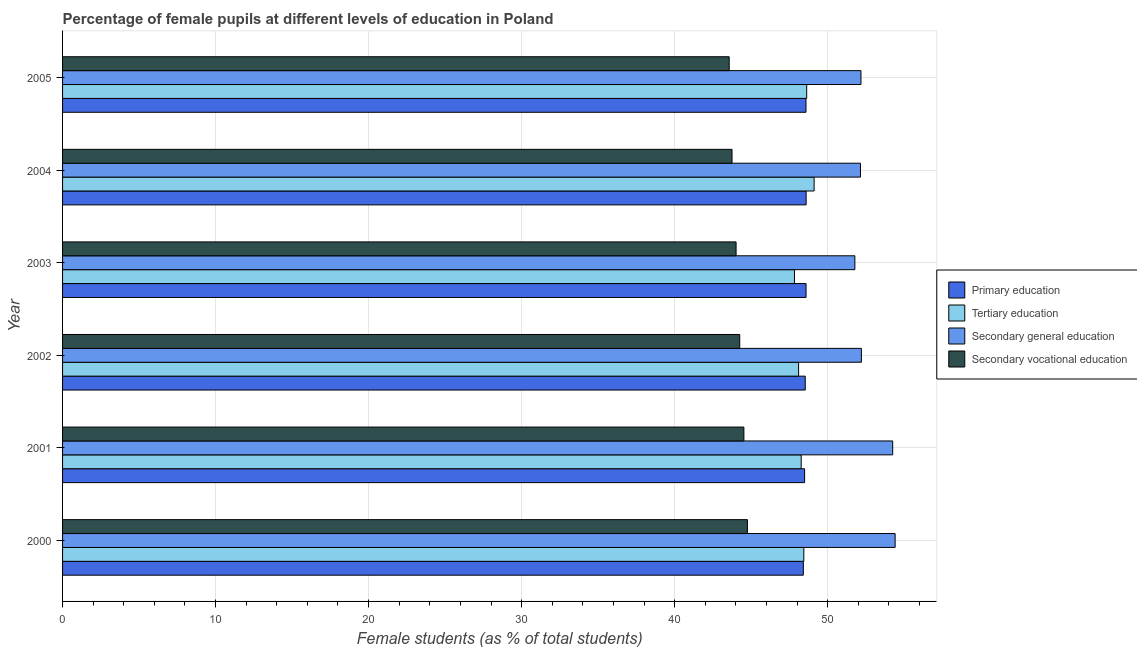How many different coloured bars are there?
Your response must be concise. 4. How many groups of bars are there?
Your answer should be very brief. 6. In how many cases, is the number of bars for a given year not equal to the number of legend labels?
Offer a very short reply. 0. What is the percentage of female students in primary education in 2005?
Offer a very short reply. 48.59. Across all years, what is the maximum percentage of female students in primary education?
Offer a terse response. 48.59. Across all years, what is the minimum percentage of female students in primary education?
Offer a very short reply. 48.41. What is the total percentage of female students in tertiary education in the graph?
Your answer should be very brief. 290.4. What is the difference between the percentage of female students in secondary vocational education in 2000 and that in 2002?
Offer a terse response. 0.5. What is the difference between the percentage of female students in tertiary education in 2003 and the percentage of female students in secondary education in 2005?
Make the answer very short. -4.35. What is the average percentage of female students in secondary education per year?
Offer a terse response. 52.83. In the year 2000, what is the difference between the percentage of female students in tertiary education and percentage of female students in secondary education?
Offer a terse response. -5.97. What is the ratio of the percentage of female students in secondary education in 2000 to that in 2004?
Ensure brevity in your answer.  1.04. Is the percentage of female students in tertiary education in 2000 less than that in 2001?
Your answer should be very brief. No. Is the difference between the percentage of female students in secondary education in 2003 and 2004 greater than the difference between the percentage of female students in secondary vocational education in 2003 and 2004?
Your answer should be very brief. No. What is the difference between the highest and the second highest percentage of female students in tertiary education?
Provide a short and direct response. 0.48. What is the difference between the highest and the lowest percentage of female students in tertiary education?
Ensure brevity in your answer.  1.28. Is it the case that in every year, the sum of the percentage of female students in primary education and percentage of female students in secondary vocational education is greater than the sum of percentage of female students in tertiary education and percentage of female students in secondary education?
Keep it short and to the point. Yes. What does the 3rd bar from the top in 2003 represents?
Make the answer very short. Tertiary education. What does the 2nd bar from the bottom in 2001 represents?
Your answer should be compact. Tertiary education. Is it the case that in every year, the sum of the percentage of female students in primary education and percentage of female students in tertiary education is greater than the percentage of female students in secondary education?
Give a very brief answer. Yes. How many bars are there?
Your answer should be compact. 24. Are the values on the major ticks of X-axis written in scientific E-notation?
Keep it short and to the point. No. Does the graph contain any zero values?
Ensure brevity in your answer.  No. Where does the legend appear in the graph?
Your answer should be very brief. Center right. How many legend labels are there?
Keep it short and to the point. 4. What is the title of the graph?
Provide a succinct answer. Percentage of female pupils at different levels of education in Poland. Does "Tertiary education" appear as one of the legend labels in the graph?
Provide a succinct answer. Yes. What is the label or title of the X-axis?
Make the answer very short. Female students (as % of total students). What is the label or title of the Y-axis?
Your response must be concise. Year. What is the Female students (as % of total students) in Primary education in 2000?
Offer a terse response. 48.41. What is the Female students (as % of total students) of Tertiary education in 2000?
Ensure brevity in your answer.  48.44. What is the Female students (as % of total students) in Secondary general education in 2000?
Provide a short and direct response. 54.41. What is the Female students (as % of total students) of Secondary vocational education in 2000?
Your response must be concise. 44.76. What is the Female students (as % of total students) of Primary education in 2001?
Give a very brief answer. 48.5. What is the Female students (as % of total students) in Tertiary education in 2001?
Provide a succinct answer. 48.27. What is the Female students (as % of total students) in Secondary general education in 2001?
Offer a terse response. 54.25. What is the Female students (as % of total students) of Secondary vocational education in 2001?
Give a very brief answer. 44.53. What is the Female students (as % of total students) of Primary education in 2002?
Provide a short and direct response. 48.54. What is the Female students (as % of total students) in Tertiary education in 2002?
Keep it short and to the point. 48.1. What is the Female students (as % of total students) of Secondary general education in 2002?
Your answer should be compact. 52.21. What is the Female students (as % of total students) in Secondary vocational education in 2002?
Your answer should be very brief. 44.26. What is the Female students (as % of total students) of Primary education in 2003?
Your answer should be compact. 48.59. What is the Female students (as % of total students) in Tertiary education in 2003?
Give a very brief answer. 47.83. What is the Female students (as % of total students) of Secondary general education in 2003?
Your answer should be compact. 51.78. What is the Female students (as % of total students) in Secondary vocational education in 2003?
Your answer should be very brief. 44.02. What is the Female students (as % of total students) in Primary education in 2004?
Offer a very short reply. 48.59. What is the Female students (as % of total students) of Tertiary education in 2004?
Offer a terse response. 49.12. What is the Female students (as % of total students) of Secondary general education in 2004?
Provide a short and direct response. 52.15. What is the Female students (as % of total students) in Secondary vocational education in 2004?
Make the answer very short. 43.75. What is the Female students (as % of total students) of Primary education in 2005?
Ensure brevity in your answer.  48.59. What is the Female students (as % of total students) in Tertiary education in 2005?
Make the answer very short. 48.63. What is the Female students (as % of total students) of Secondary general education in 2005?
Offer a terse response. 52.18. What is the Female students (as % of total students) of Secondary vocational education in 2005?
Ensure brevity in your answer.  43.57. Across all years, what is the maximum Female students (as % of total students) in Primary education?
Ensure brevity in your answer.  48.59. Across all years, what is the maximum Female students (as % of total students) in Tertiary education?
Ensure brevity in your answer.  49.12. Across all years, what is the maximum Female students (as % of total students) in Secondary general education?
Your response must be concise. 54.41. Across all years, what is the maximum Female students (as % of total students) of Secondary vocational education?
Ensure brevity in your answer.  44.76. Across all years, what is the minimum Female students (as % of total students) of Primary education?
Provide a short and direct response. 48.41. Across all years, what is the minimum Female students (as % of total students) in Tertiary education?
Offer a very short reply. 47.83. Across all years, what is the minimum Female students (as % of total students) in Secondary general education?
Provide a succinct answer. 51.78. Across all years, what is the minimum Female students (as % of total students) of Secondary vocational education?
Offer a terse response. 43.57. What is the total Female students (as % of total students) in Primary education in the graph?
Keep it short and to the point. 291.21. What is the total Female students (as % of total students) of Tertiary education in the graph?
Provide a succinct answer. 290.4. What is the total Female students (as % of total students) in Secondary general education in the graph?
Make the answer very short. 316.98. What is the total Female students (as % of total students) in Secondary vocational education in the graph?
Your answer should be very brief. 264.88. What is the difference between the Female students (as % of total students) in Primary education in 2000 and that in 2001?
Offer a very short reply. -0.08. What is the difference between the Female students (as % of total students) of Tertiary education in 2000 and that in 2001?
Your answer should be compact. 0.17. What is the difference between the Female students (as % of total students) in Secondary general education in 2000 and that in 2001?
Keep it short and to the point. 0.16. What is the difference between the Female students (as % of total students) in Secondary vocational education in 2000 and that in 2001?
Your answer should be very brief. 0.23. What is the difference between the Female students (as % of total students) of Primary education in 2000 and that in 2002?
Make the answer very short. -0.12. What is the difference between the Female students (as % of total students) in Tertiary education in 2000 and that in 2002?
Ensure brevity in your answer.  0.34. What is the difference between the Female students (as % of total students) of Secondary general education in 2000 and that in 2002?
Ensure brevity in your answer.  2.2. What is the difference between the Female students (as % of total students) of Secondary vocational education in 2000 and that in 2002?
Make the answer very short. 0.5. What is the difference between the Female students (as % of total students) of Primary education in 2000 and that in 2003?
Offer a terse response. -0.18. What is the difference between the Female students (as % of total students) of Tertiary education in 2000 and that in 2003?
Offer a terse response. 0.61. What is the difference between the Female students (as % of total students) in Secondary general education in 2000 and that in 2003?
Ensure brevity in your answer.  2.63. What is the difference between the Female students (as % of total students) in Secondary vocational education in 2000 and that in 2003?
Ensure brevity in your answer.  0.74. What is the difference between the Female students (as % of total students) in Primary education in 2000 and that in 2004?
Offer a very short reply. -0.18. What is the difference between the Female students (as % of total students) of Tertiary education in 2000 and that in 2004?
Offer a very short reply. -0.67. What is the difference between the Female students (as % of total students) of Secondary general education in 2000 and that in 2004?
Your answer should be compact. 2.27. What is the difference between the Female students (as % of total students) in Secondary vocational education in 2000 and that in 2004?
Make the answer very short. 1.01. What is the difference between the Female students (as % of total students) of Primary education in 2000 and that in 2005?
Keep it short and to the point. -0.17. What is the difference between the Female students (as % of total students) in Tertiary education in 2000 and that in 2005?
Ensure brevity in your answer.  -0.19. What is the difference between the Female students (as % of total students) of Secondary general education in 2000 and that in 2005?
Offer a very short reply. 2.23. What is the difference between the Female students (as % of total students) of Secondary vocational education in 2000 and that in 2005?
Give a very brief answer. 1.19. What is the difference between the Female students (as % of total students) of Primary education in 2001 and that in 2002?
Give a very brief answer. -0.04. What is the difference between the Female students (as % of total students) in Tertiary education in 2001 and that in 2002?
Your response must be concise. 0.17. What is the difference between the Female students (as % of total students) of Secondary general education in 2001 and that in 2002?
Offer a very short reply. 2.05. What is the difference between the Female students (as % of total students) in Secondary vocational education in 2001 and that in 2002?
Ensure brevity in your answer.  0.27. What is the difference between the Female students (as % of total students) of Primary education in 2001 and that in 2003?
Your answer should be very brief. -0.09. What is the difference between the Female students (as % of total students) of Tertiary education in 2001 and that in 2003?
Offer a terse response. 0.44. What is the difference between the Female students (as % of total students) in Secondary general education in 2001 and that in 2003?
Give a very brief answer. 2.47. What is the difference between the Female students (as % of total students) in Secondary vocational education in 2001 and that in 2003?
Your answer should be very brief. 0.51. What is the difference between the Female students (as % of total students) of Primary education in 2001 and that in 2004?
Keep it short and to the point. -0.1. What is the difference between the Female students (as % of total students) in Tertiary education in 2001 and that in 2004?
Offer a very short reply. -0.84. What is the difference between the Female students (as % of total students) in Secondary general education in 2001 and that in 2004?
Your answer should be compact. 2.11. What is the difference between the Female students (as % of total students) in Secondary vocational education in 2001 and that in 2004?
Ensure brevity in your answer.  0.78. What is the difference between the Female students (as % of total students) in Primary education in 2001 and that in 2005?
Your answer should be very brief. -0.09. What is the difference between the Female students (as % of total students) of Tertiary education in 2001 and that in 2005?
Give a very brief answer. -0.36. What is the difference between the Female students (as % of total students) of Secondary general education in 2001 and that in 2005?
Your answer should be very brief. 2.08. What is the difference between the Female students (as % of total students) of Secondary vocational education in 2001 and that in 2005?
Make the answer very short. 0.96. What is the difference between the Female students (as % of total students) in Primary education in 2002 and that in 2003?
Provide a short and direct response. -0.05. What is the difference between the Female students (as % of total students) in Tertiary education in 2002 and that in 2003?
Your response must be concise. 0.27. What is the difference between the Female students (as % of total students) in Secondary general education in 2002 and that in 2003?
Give a very brief answer. 0.43. What is the difference between the Female students (as % of total students) in Secondary vocational education in 2002 and that in 2003?
Make the answer very short. 0.24. What is the difference between the Female students (as % of total students) of Primary education in 2002 and that in 2004?
Your answer should be very brief. -0.06. What is the difference between the Female students (as % of total students) in Tertiary education in 2002 and that in 2004?
Give a very brief answer. -1.01. What is the difference between the Female students (as % of total students) in Secondary general education in 2002 and that in 2004?
Make the answer very short. 0.06. What is the difference between the Female students (as % of total students) in Secondary vocational education in 2002 and that in 2004?
Offer a very short reply. 0.5. What is the difference between the Female students (as % of total students) of Primary education in 2002 and that in 2005?
Offer a terse response. -0.05. What is the difference between the Female students (as % of total students) in Tertiary education in 2002 and that in 2005?
Provide a succinct answer. -0.53. What is the difference between the Female students (as % of total students) in Secondary general education in 2002 and that in 2005?
Give a very brief answer. 0.03. What is the difference between the Female students (as % of total students) of Secondary vocational education in 2002 and that in 2005?
Your answer should be very brief. 0.69. What is the difference between the Female students (as % of total students) in Primary education in 2003 and that in 2004?
Make the answer very short. -0. What is the difference between the Female students (as % of total students) of Tertiary education in 2003 and that in 2004?
Provide a short and direct response. -1.28. What is the difference between the Female students (as % of total students) of Secondary general education in 2003 and that in 2004?
Your answer should be compact. -0.37. What is the difference between the Female students (as % of total students) in Secondary vocational education in 2003 and that in 2004?
Provide a short and direct response. 0.26. What is the difference between the Female students (as % of total students) of Primary education in 2003 and that in 2005?
Ensure brevity in your answer.  0. What is the difference between the Female students (as % of total students) in Tertiary education in 2003 and that in 2005?
Provide a short and direct response. -0.8. What is the difference between the Female students (as % of total students) in Secondary general education in 2003 and that in 2005?
Keep it short and to the point. -0.4. What is the difference between the Female students (as % of total students) in Secondary vocational education in 2003 and that in 2005?
Offer a very short reply. 0.45. What is the difference between the Female students (as % of total students) in Primary education in 2004 and that in 2005?
Keep it short and to the point. 0.01. What is the difference between the Female students (as % of total students) in Tertiary education in 2004 and that in 2005?
Keep it short and to the point. 0.49. What is the difference between the Female students (as % of total students) of Secondary general education in 2004 and that in 2005?
Provide a succinct answer. -0.03. What is the difference between the Female students (as % of total students) of Secondary vocational education in 2004 and that in 2005?
Offer a terse response. 0.19. What is the difference between the Female students (as % of total students) in Primary education in 2000 and the Female students (as % of total students) in Tertiary education in 2001?
Your response must be concise. 0.14. What is the difference between the Female students (as % of total students) of Primary education in 2000 and the Female students (as % of total students) of Secondary general education in 2001?
Your response must be concise. -5.84. What is the difference between the Female students (as % of total students) in Primary education in 2000 and the Female students (as % of total students) in Secondary vocational education in 2001?
Provide a succinct answer. 3.88. What is the difference between the Female students (as % of total students) in Tertiary education in 2000 and the Female students (as % of total students) in Secondary general education in 2001?
Give a very brief answer. -5.81. What is the difference between the Female students (as % of total students) of Tertiary education in 2000 and the Female students (as % of total students) of Secondary vocational education in 2001?
Your answer should be compact. 3.92. What is the difference between the Female students (as % of total students) of Secondary general education in 2000 and the Female students (as % of total students) of Secondary vocational education in 2001?
Give a very brief answer. 9.88. What is the difference between the Female students (as % of total students) of Primary education in 2000 and the Female students (as % of total students) of Tertiary education in 2002?
Give a very brief answer. 0.31. What is the difference between the Female students (as % of total students) in Primary education in 2000 and the Female students (as % of total students) in Secondary general education in 2002?
Ensure brevity in your answer.  -3.79. What is the difference between the Female students (as % of total students) in Primary education in 2000 and the Female students (as % of total students) in Secondary vocational education in 2002?
Offer a terse response. 4.16. What is the difference between the Female students (as % of total students) in Tertiary education in 2000 and the Female students (as % of total students) in Secondary general education in 2002?
Ensure brevity in your answer.  -3.76. What is the difference between the Female students (as % of total students) in Tertiary education in 2000 and the Female students (as % of total students) in Secondary vocational education in 2002?
Offer a very short reply. 4.19. What is the difference between the Female students (as % of total students) in Secondary general education in 2000 and the Female students (as % of total students) in Secondary vocational education in 2002?
Offer a very short reply. 10.16. What is the difference between the Female students (as % of total students) in Primary education in 2000 and the Female students (as % of total students) in Tertiary education in 2003?
Your answer should be compact. 0.58. What is the difference between the Female students (as % of total students) of Primary education in 2000 and the Female students (as % of total students) of Secondary general education in 2003?
Your answer should be very brief. -3.37. What is the difference between the Female students (as % of total students) in Primary education in 2000 and the Female students (as % of total students) in Secondary vocational education in 2003?
Offer a terse response. 4.4. What is the difference between the Female students (as % of total students) of Tertiary education in 2000 and the Female students (as % of total students) of Secondary general education in 2003?
Ensure brevity in your answer.  -3.34. What is the difference between the Female students (as % of total students) of Tertiary education in 2000 and the Female students (as % of total students) of Secondary vocational education in 2003?
Your answer should be compact. 4.43. What is the difference between the Female students (as % of total students) in Secondary general education in 2000 and the Female students (as % of total students) in Secondary vocational education in 2003?
Give a very brief answer. 10.39. What is the difference between the Female students (as % of total students) in Primary education in 2000 and the Female students (as % of total students) in Tertiary education in 2004?
Keep it short and to the point. -0.7. What is the difference between the Female students (as % of total students) in Primary education in 2000 and the Female students (as % of total students) in Secondary general education in 2004?
Make the answer very short. -3.73. What is the difference between the Female students (as % of total students) of Primary education in 2000 and the Female students (as % of total students) of Secondary vocational education in 2004?
Your answer should be compact. 4.66. What is the difference between the Female students (as % of total students) of Tertiary education in 2000 and the Female students (as % of total students) of Secondary general education in 2004?
Your response must be concise. -3.7. What is the difference between the Female students (as % of total students) of Tertiary education in 2000 and the Female students (as % of total students) of Secondary vocational education in 2004?
Provide a short and direct response. 4.69. What is the difference between the Female students (as % of total students) of Secondary general education in 2000 and the Female students (as % of total students) of Secondary vocational education in 2004?
Give a very brief answer. 10.66. What is the difference between the Female students (as % of total students) in Primary education in 2000 and the Female students (as % of total students) in Tertiary education in 2005?
Your response must be concise. -0.22. What is the difference between the Female students (as % of total students) in Primary education in 2000 and the Female students (as % of total students) in Secondary general education in 2005?
Provide a succinct answer. -3.77. What is the difference between the Female students (as % of total students) in Primary education in 2000 and the Female students (as % of total students) in Secondary vocational education in 2005?
Ensure brevity in your answer.  4.85. What is the difference between the Female students (as % of total students) of Tertiary education in 2000 and the Female students (as % of total students) of Secondary general education in 2005?
Offer a terse response. -3.73. What is the difference between the Female students (as % of total students) in Tertiary education in 2000 and the Female students (as % of total students) in Secondary vocational education in 2005?
Ensure brevity in your answer.  4.88. What is the difference between the Female students (as % of total students) in Secondary general education in 2000 and the Female students (as % of total students) in Secondary vocational education in 2005?
Your response must be concise. 10.85. What is the difference between the Female students (as % of total students) in Primary education in 2001 and the Female students (as % of total students) in Tertiary education in 2002?
Keep it short and to the point. 0.39. What is the difference between the Female students (as % of total students) in Primary education in 2001 and the Female students (as % of total students) in Secondary general education in 2002?
Keep it short and to the point. -3.71. What is the difference between the Female students (as % of total students) in Primary education in 2001 and the Female students (as % of total students) in Secondary vocational education in 2002?
Offer a very short reply. 4.24. What is the difference between the Female students (as % of total students) in Tertiary education in 2001 and the Female students (as % of total students) in Secondary general education in 2002?
Your response must be concise. -3.93. What is the difference between the Female students (as % of total students) of Tertiary education in 2001 and the Female students (as % of total students) of Secondary vocational education in 2002?
Make the answer very short. 4.02. What is the difference between the Female students (as % of total students) in Secondary general education in 2001 and the Female students (as % of total students) in Secondary vocational education in 2002?
Give a very brief answer. 10. What is the difference between the Female students (as % of total students) in Primary education in 2001 and the Female students (as % of total students) in Tertiary education in 2003?
Provide a succinct answer. 0.66. What is the difference between the Female students (as % of total students) of Primary education in 2001 and the Female students (as % of total students) of Secondary general education in 2003?
Offer a very short reply. -3.28. What is the difference between the Female students (as % of total students) of Primary education in 2001 and the Female students (as % of total students) of Secondary vocational education in 2003?
Give a very brief answer. 4.48. What is the difference between the Female students (as % of total students) in Tertiary education in 2001 and the Female students (as % of total students) in Secondary general education in 2003?
Your answer should be compact. -3.51. What is the difference between the Female students (as % of total students) in Tertiary education in 2001 and the Female students (as % of total students) in Secondary vocational education in 2003?
Keep it short and to the point. 4.26. What is the difference between the Female students (as % of total students) in Secondary general education in 2001 and the Female students (as % of total students) in Secondary vocational education in 2003?
Your answer should be compact. 10.24. What is the difference between the Female students (as % of total students) of Primary education in 2001 and the Female students (as % of total students) of Tertiary education in 2004?
Ensure brevity in your answer.  -0.62. What is the difference between the Female students (as % of total students) of Primary education in 2001 and the Female students (as % of total students) of Secondary general education in 2004?
Ensure brevity in your answer.  -3.65. What is the difference between the Female students (as % of total students) of Primary education in 2001 and the Female students (as % of total students) of Secondary vocational education in 2004?
Keep it short and to the point. 4.74. What is the difference between the Female students (as % of total students) of Tertiary education in 2001 and the Female students (as % of total students) of Secondary general education in 2004?
Provide a short and direct response. -3.87. What is the difference between the Female students (as % of total students) in Tertiary education in 2001 and the Female students (as % of total students) in Secondary vocational education in 2004?
Keep it short and to the point. 4.52. What is the difference between the Female students (as % of total students) in Secondary general education in 2001 and the Female students (as % of total students) in Secondary vocational education in 2004?
Your answer should be very brief. 10.5. What is the difference between the Female students (as % of total students) in Primary education in 2001 and the Female students (as % of total students) in Tertiary education in 2005?
Make the answer very short. -0.14. What is the difference between the Female students (as % of total students) of Primary education in 2001 and the Female students (as % of total students) of Secondary general education in 2005?
Give a very brief answer. -3.68. What is the difference between the Female students (as % of total students) of Primary education in 2001 and the Female students (as % of total students) of Secondary vocational education in 2005?
Make the answer very short. 4.93. What is the difference between the Female students (as % of total students) in Tertiary education in 2001 and the Female students (as % of total students) in Secondary general education in 2005?
Your answer should be compact. -3.9. What is the difference between the Female students (as % of total students) in Tertiary education in 2001 and the Female students (as % of total students) in Secondary vocational education in 2005?
Provide a short and direct response. 4.71. What is the difference between the Female students (as % of total students) in Secondary general education in 2001 and the Female students (as % of total students) in Secondary vocational education in 2005?
Provide a short and direct response. 10.69. What is the difference between the Female students (as % of total students) in Primary education in 2002 and the Female students (as % of total students) in Tertiary education in 2003?
Your response must be concise. 0.7. What is the difference between the Female students (as % of total students) in Primary education in 2002 and the Female students (as % of total students) in Secondary general education in 2003?
Ensure brevity in your answer.  -3.24. What is the difference between the Female students (as % of total students) of Primary education in 2002 and the Female students (as % of total students) of Secondary vocational education in 2003?
Offer a terse response. 4.52. What is the difference between the Female students (as % of total students) of Tertiary education in 2002 and the Female students (as % of total students) of Secondary general education in 2003?
Provide a short and direct response. -3.68. What is the difference between the Female students (as % of total students) in Tertiary education in 2002 and the Female students (as % of total students) in Secondary vocational education in 2003?
Ensure brevity in your answer.  4.09. What is the difference between the Female students (as % of total students) in Secondary general education in 2002 and the Female students (as % of total students) in Secondary vocational education in 2003?
Make the answer very short. 8.19. What is the difference between the Female students (as % of total students) in Primary education in 2002 and the Female students (as % of total students) in Tertiary education in 2004?
Offer a terse response. -0.58. What is the difference between the Female students (as % of total students) of Primary education in 2002 and the Female students (as % of total students) of Secondary general education in 2004?
Give a very brief answer. -3.61. What is the difference between the Female students (as % of total students) of Primary education in 2002 and the Female students (as % of total students) of Secondary vocational education in 2004?
Keep it short and to the point. 4.78. What is the difference between the Female students (as % of total students) of Tertiary education in 2002 and the Female students (as % of total students) of Secondary general education in 2004?
Your answer should be very brief. -4.04. What is the difference between the Female students (as % of total students) in Tertiary education in 2002 and the Female students (as % of total students) in Secondary vocational education in 2004?
Provide a succinct answer. 4.35. What is the difference between the Female students (as % of total students) in Secondary general education in 2002 and the Female students (as % of total students) in Secondary vocational education in 2004?
Provide a short and direct response. 8.45. What is the difference between the Female students (as % of total students) of Primary education in 2002 and the Female students (as % of total students) of Tertiary education in 2005?
Your answer should be very brief. -0.1. What is the difference between the Female students (as % of total students) in Primary education in 2002 and the Female students (as % of total students) in Secondary general education in 2005?
Your answer should be very brief. -3.64. What is the difference between the Female students (as % of total students) of Primary education in 2002 and the Female students (as % of total students) of Secondary vocational education in 2005?
Your answer should be very brief. 4.97. What is the difference between the Female students (as % of total students) in Tertiary education in 2002 and the Female students (as % of total students) in Secondary general education in 2005?
Provide a succinct answer. -4.08. What is the difference between the Female students (as % of total students) of Tertiary education in 2002 and the Female students (as % of total students) of Secondary vocational education in 2005?
Your answer should be very brief. 4.54. What is the difference between the Female students (as % of total students) of Secondary general education in 2002 and the Female students (as % of total students) of Secondary vocational education in 2005?
Your response must be concise. 8.64. What is the difference between the Female students (as % of total students) in Primary education in 2003 and the Female students (as % of total students) in Tertiary education in 2004?
Provide a short and direct response. -0.53. What is the difference between the Female students (as % of total students) in Primary education in 2003 and the Female students (as % of total students) in Secondary general education in 2004?
Provide a short and direct response. -3.56. What is the difference between the Female students (as % of total students) in Primary education in 2003 and the Female students (as % of total students) in Secondary vocational education in 2004?
Offer a very short reply. 4.84. What is the difference between the Female students (as % of total students) of Tertiary education in 2003 and the Female students (as % of total students) of Secondary general education in 2004?
Give a very brief answer. -4.31. What is the difference between the Female students (as % of total students) of Tertiary education in 2003 and the Female students (as % of total students) of Secondary vocational education in 2004?
Offer a terse response. 4.08. What is the difference between the Female students (as % of total students) in Secondary general education in 2003 and the Female students (as % of total students) in Secondary vocational education in 2004?
Offer a terse response. 8.03. What is the difference between the Female students (as % of total students) in Primary education in 2003 and the Female students (as % of total students) in Tertiary education in 2005?
Provide a short and direct response. -0.04. What is the difference between the Female students (as % of total students) in Primary education in 2003 and the Female students (as % of total students) in Secondary general education in 2005?
Keep it short and to the point. -3.59. What is the difference between the Female students (as % of total students) of Primary education in 2003 and the Female students (as % of total students) of Secondary vocational education in 2005?
Offer a terse response. 5.02. What is the difference between the Female students (as % of total students) of Tertiary education in 2003 and the Female students (as % of total students) of Secondary general education in 2005?
Your answer should be compact. -4.34. What is the difference between the Female students (as % of total students) in Tertiary education in 2003 and the Female students (as % of total students) in Secondary vocational education in 2005?
Provide a succinct answer. 4.27. What is the difference between the Female students (as % of total students) of Secondary general education in 2003 and the Female students (as % of total students) of Secondary vocational education in 2005?
Keep it short and to the point. 8.21. What is the difference between the Female students (as % of total students) of Primary education in 2004 and the Female students (as % of total students) of Tertiary education in 2005?
Your answer should be compact. -0.04. What is the difference between the Female students (as % of total students) of Primary education in 2004 and the Female students (as % of total students) of Secondary general education in 2005?
Make the answer very short. -3.58. What is the difference between the Female students (as % of total students) of Primary education in 2004 and the Female students (as % of total students) of Secondary vocational education in 2005?
Offer a terse response. 5.03. What is the difference between the Female students (as % of total students) in Tertiary education in 2004 and the Female students (as % of total students) in Secondary general education in 2005?
Your answer should be very brief. -3.06. What is the difference between the Female students (as % of total students) of Tertiary education in 2004 and the Female students (as % of total students) of Secondary vocational education in 2005?
Your response must be concise. 5.55. What is the difference between the Female students (as % of total students) of Secondary general education in 2004 and the Female students (as % of total students) of Secondary vocational education in 2005?
Give a very brief answer. 8.58. What is the average Female students (as % of total students) of Primary education per year?
Provide a succinct answer. 48.54. What is the average Female students (as % of total students) in Tertiary education per year?
Your response must be concise. 48.4. What is the average Female students (as % of total students) in Secondary general education per year?
Provide a short and direct response. 52.83. What is the average Female students (as % of total students) in Secondary vocational education per year?
Make the answer very short. 44.15. In the year 2000, what is the difference between the Female students (as % of total students) in Primary education and Female students (as % of total students) in Tertiary education?
Provide a short and direct response. -0.03. In the year 2000, what is the difference between the Female students (as % of total students) in Primary education and Female students (as % of total students) in Secondary general education?
Keep it short and to the point. -6. In the year 2000, what is the difference between the Female students (as % of total students) in Primary education and Female students (as % of total students) in Secondary vocational education?
Provide a short and direct response. 3.65. In the year 2000, what is the difference between the Female students (as % of total students) of Tertiary education and Female students (as % of total students) of Secondary general education?
Offer a terse response. -5.97. In the year 2000, what is the difference between the Female students (as % of total students) of Tertiary education and Female students (as % of total students) of Secondary vocational education?
Your answer should be compact. 3.69. In the year 2000, what is the difference between the Female students (as % of total students) of Secondary general education and Female students (as % of total students) of Secondary vocational education?
Offer a terse response. 9.65. In the year 2001, what is the difference between the Female students (as % of total students) of Primary education and Female students (as % of total students) of Tertiary education?
Offer a very short reply. 0.22. In the year 2001, what is the difference between the Female students (as % of total students) of Primary education and Female students (as % of total students) of Secondary general education?
Make the answer very short. -5.76. In the year 2001, what is the difference between the Female students (as % of total students) in Primary education and Female students (as % of total students) in Secondary vocational education?
Offer a very short reply. 3.97. In the year 2001, what is the difference between the Female students (as % of total students) in Tertiary education and Female students (as % of total students) in Secondary general education?
Your response must be concise. -5.98. In the year 2001, what is the difference between the Female students (as % of total students) of Tertiary education and Female students (as % of total students) of Secondary vocational education?
Offer a very short reply. 3.75. In the year 2001, what is the difference between the Female students (as % of total students) of Secondary general education and Female students (as % of total students) of Secondary vocational education?
Make the answer very short. 9.73. In the year 2002, what is the difference between the Female students (as % of total students) of Primary education and Female students (as % of total students) of Tertiary education?
Keep it short and to the point. 0.43. In the year 2002, what is the difference between the Female students (as % of total students) of Primary education and Female students (as % of total students) of Secondary general education?
Offer a terse response. -3.67. In the year 2002, what is the difference between the Female students (as % of total students) of Primary education and Female students (as % of total students) of Secondary vocational education?
Offer a terse response. 4.28. In the year 2002, what is the difference between the Female students (as % of total students) of Tertiary education and Female students (as % of total students) of Secondary general education?
Keep it short and to the point. -4.1. In the year 2002, what is the difference between the Female students (as % of total students) in Tertiary education and Female students (as % of total students) in Secondary vocational education?
Your answer should be compact. 3.85. In the year 2002, what is the difference between the Female students (as % of total students) in Secondary general education and Female students (as % of total students) in Secondary vocational education?
Your answer should be very brief. 7.95. In the year 2003, what is the difference between the Female students (as % of total students) in Primary education and Female students (as % of total students) in Tertiary education?
Ensure brevity in your answer.  0.76. In the year 2003, what is the difference between the Female students (as % of total students) in Primary education and Female students (as % of total students) in Secondary general education?
Offer a very short reply. -3.19. In the year 2003, what is the difference between the Female students (as % of total students) of Primary education and Female students (as % of total students) of Secondary vocational education?
Your response must be concise. 4.57. In the year 2003, what is the difference between the Female students (as % of total students) of Tertiary education and Female students (as % of total students) of Secondary general education?
Your response must be concise. -3.95. In the year 2003, what is the difference between the Female students (as % of total students) of Tertiary education and Female students (as % of total students) of Secondary vocational education?
Provide a succinct answer. 3.82. In the year 2003, what is the difference between the Female students (as % of total students) of Secondary general education and Female students (as % of total students) of Secondary vocational education?
Your answer should be compact. 7.76. In the year 2004, what is the difference between the Female students (as % of total students) in Primary education and Female students (as % of total students) in Tertiary education?
Your answer should be very brief. -0.52. In the year 2004, what is the difference between the Female students (as % of total students) of Primary education and Female students (as % of total students) of Secondary general education?
Ensure brevity in your answer.  -3.55. In the year 2004, what is the difference between the Female students (as % of total students) of Primary education and Female students (as % of total students) of Secondary vocational education?
Your answer should be very brief. 4.84. In the year 2004, what is the difference between the Female students (as % of total students) in Tertiary education and Female students (as % of total students) in Secondary general education?
Offer a very short reply. -3.03. In the year 2004, what is the difference between the Female students (as % of total students) in Tertiary education and Female students (as % of total students) in Secondary vocational education?
Keep it short and to the point. 5.36. In the year 2004, what is the difference between the Female students (as % of total students) in Secondary general education and Female students (as % of total students) in Secondary vocational education?
Your answer should be compact. 8.39. In the year 2005, what is the difference between the Female students (as % of total students) in Primary education and Female students (as % of total students) in Tertiary education?
Keep it short and to the point. -0.05. In the year 2005, what is the difference between the Female students (as % of total students) in Primary education and Female students (as % of total students) in Secondary general education?
Make the answer very short. -3.59. In the year 2005, what is the difference between the Female students (as % of total students) of Primary education and Female students (as % of total students) of Secondary vocational education?
Provide a succinct answer. 5.02. In the year 2005, what is the difference between the Female students (as % of total students) in Tertiary education and Female students (as % of total students) in Secondary general education?
Provide a short and direct response. -3.55. In the year 2005, what is the difference between the Female students (as % of total students) in Tertiary education and Female students (as % of total students) in Secondary vocational education?
Provide a succinct answer. 5.07. In the year 2005, what is the difference between the Female students (as % of total students) in Secondary general education and Female students (as % of total students) in Secondary vocational education?
Make the answer very short. 8.61. What is the ratio of the Female students (as % of total students) of Primary education in 2000 to that in 2001?
Offer a very short reply. 1. What is the ratio of the Female students (as % of total students) of Secondary vocational education in 2000 to that in 2001?
Make the answer very short. 1.01. What is the ratio of the Female students (as % of total students) of Tertiary education in 2000 to that in 2002?
Make the answer very short. 1.01. What is the ratio of the Female students (as % of total students) of Secondary general education in 2000 to that in 2002?
Make the answer very short. 1.04. What is the ratio of the Female students (as % of total students) of Secondary vocational education in 2000 to that in 2002?
Ensure brevity in your answer.  1.01. What is the ratio of the Female students (as % of total students) of Primary education in 2000 to that in 2003?
Your answer should be very brief. 1. What is the ratio of the Female students (as % of total students) in Tertiary education in 2000 to that in 2003?
Your answer should be compact. 1.01. What is the ratio of the Female students (as % of total students) of Secondary general education in 2000 to that in 2003?
Give a very brief answer. 1.05. What is the ratio of the Female students (as % of total students) in Secondary vocational education in 2000 to that in 2003?
Ensure brevity in your answer.  1.02. What is the ratio of the Female students (as % of total students) of Primary education in 2000 to that in 2004?
Give a very brief answer. 1. What is the ratio of the Female students (as % of total students) in Tertiary education in 2000 to that in 2004?
Offer a very short reply. 0.99. What is the ratio of the Female students (as % of total students) in Secondary general education in 2000 to that in 2004?
Give a very brief answer. 1.04. What is the ratio of the Female students (as % of total students) in Secondary vocational education in 2000 to that in 2004?
Make the answer very short. 1.02. What is the ratio of the Female students (as % of total students) in Primary education in 2000 to that in 2005?
Your answer should be very brief. 1. What is the ratio of the Female students (as % of total students) in Tertiary education in 2000 to that in 2005?
Ensure brevity in your answer.  1. What is the ratio of the Female students (as % of total students) of Secondary general education in 2000 to that in 2005?
Your response must be concise. 1.04. What is the ratio of the Female students (as % of total students) of Secondary vocational education in 2000 to that in 2005?
Give a very brief answer. 1.03. What is the ratio of the Female students (as % of total students) of Primary education in 2001 to that in 2002?
Give a very brief answer. 1. What is the ratio of the Female students (as % of total students) of Secondary general education in 2001 to that in 2002?
Your answer should be compact. 1.04. What is the ratio of the Female students (as % of total students) in Secondary vocational education in 2001 to that in 2002?
Your answer should be compact. 1.01. What is the ratio of the Female students (as % of total students) in Primary education in 2001 to that in 2003?
Provide a short and direct response. 1. What is the ratio of the Female students (as % of total students) of Tertiary education in 2001 to that in 2003?
Ensure brevity in your answer.  1.01. What is the ratio of the Female students (as % of total students) in Secondary general education in 2001 to that in 2003?
Keep it short and to the point. 1.05. What is the ratio of the Female students (as % of total students) in Secondary vocational education in 2001 to that in 2003?
Your answer should be very brief. 1.01. What is the ratio of the Female students (as % of total students) in Primary education in 2001 to that in 2004?
Provide a succinct answer. 1. What is the ratio of the Female students (as % of total students) of Tertiary education in 2001 to that in 2004?
Your response must be concise. 0.98. What is the ratio of the Female students (as % of total students) in Secondary general education in 2001 to that in 2004?
Keep it short and to the point. 1.04. What is the ratio of the Female students (as % of total students) of Secondary vocational education in 2001 to that in 2004?
Keep it short and to the point. 1.02. What is the ratio of the Female students (as % of total students) in Secondary general education in 2001 to that in 2005?
Keep it short and to the point. 1.04. What is the ratio of the Female students (as % of total students) of Secondary vocational education in 2001 to that in 2005?
Ensure brevity in your answer.  1.02. What is the ratio of the Female students (as % of total students) of Tertiary education in 2002 to that in 2003?
Make the answer very short. 1.01. What is the ratio of the Female students (as % of total students) in Secondary general education in 2002 to that in 2003?
Your answer should be compact. 1.01. What is the ratio of the Female students (as % of total students) of Secondary vocational education in 2002 to that in 2003?
Your response must be concise. 1.01. What is the ratio of the Female students (as % of total students) of Tertiary education in 2002 to that in 2004?
Keep it short and to the point. 0.98. What is the ratio of the Female students (as % of total students) in Secondary vocational education in 2002 to that in 2004?
Provide a short and direct response. 1.01. What is the ratio of the Female students (as % of total students) in Primary education in 2002 to that in 2005?
Offer a terse response. 1. What is the ratio of the Female students (as % of total students) of Secondary general education in 2002 to that in 2005?
Provide a short and direct response. 1. What is the ratio of the Female students (as % of total students) in Secondary vocational education in 2002 to that in 2005?
Provide a short and direct response. 1.02. What is the ratio of the Female students (as % of total students) in Tertiary education in 2003 to that in 2004?
Offer a terse response. 0.97. What is the ratio of the Female students (as % of total students) of Secondary vocational education in 2003 to that in 2004?
Your answer should be compact. 1.01. What is the ratio of the Female students (as % of total students) in Primary education in 2003 to that in 2005?
Give a very brief answer. 1. What is the ratio of the Female students (as % of total students) of Tertiary education in 2003 to that in 2005?
Offer a terse response. 0.98. What is the ratio of the Female students (as % of total students) in Secondary general education in 2003 to that in 2005?
Keep it short and to the point. 0.99. What is the ratio of the Female students (as % of total students) in Secondary vocational education in 2003 to that in 2005?
Provide a succinct answer. 1.01. What is the ratio of the Female students (as % of total students) in Primary education in 2004 to that in 2005?
Give a very brief answer. 1. What is the difference between the highest and the second highest Female students (as % of total students) of Primary education?
Ensure brevity in your answer.  0. What is the difference between the highest and the second highest Female students (as % of total students) in Tertiary education?
Give a very brief answer. 0.49. What is the difference between the highest and the second highest Female students (as % of total students) of Secondary general education?
Ensure brevity in your answer.  0.16. What is the difference between the highest and the second highest Female students (as % of total students) of Secondary vocational education?
Your answer should be compact. 0.23. What is the difference between the highest and the lowest Female students (as % of total students) of Primary education?
Your answer should be compact. 0.18. What is the difference between the highest and the lowest Female students (as % of total students) in Tertiary education?
Provide a succinct answer. 1.28. What is the difference between the highest and the lowest Female students (as % of total students) of Secondary general education?
Make the answer very short. 2.63. What is the difference between the highest and the lowest Female students (as % of total students) of Secondary vocational education?
Your answer should be very brief. 1.19. 